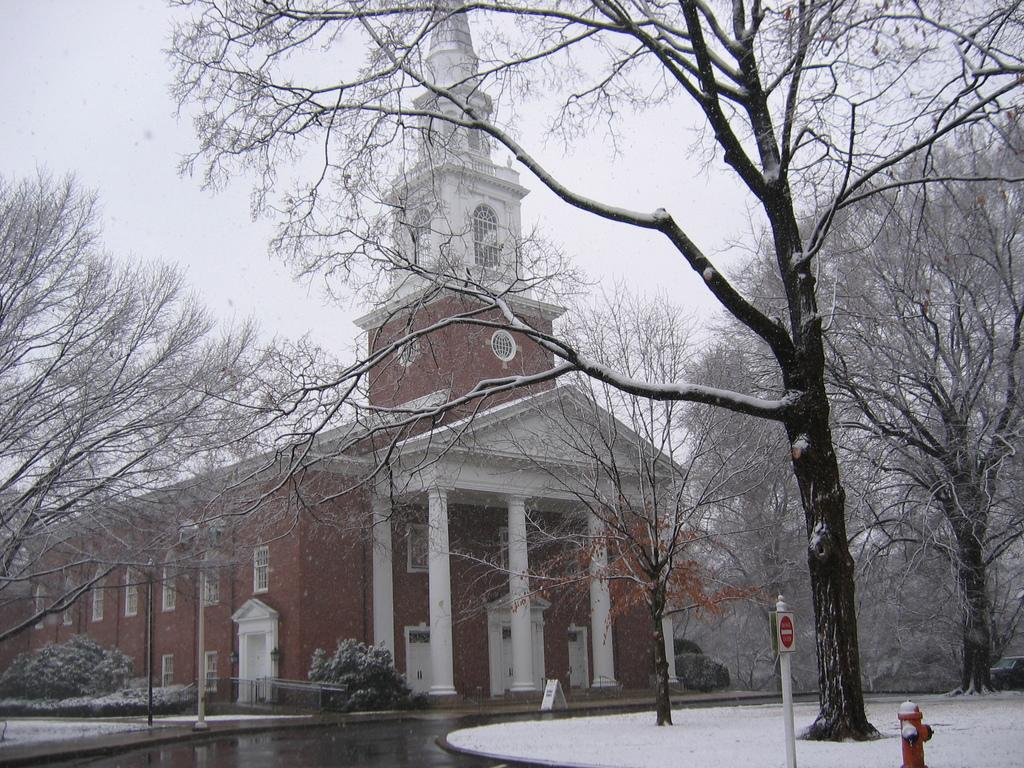What type of structure is present in the image? There is a building in the image. What natural element can be seen in the image? There is water visible in the image. What type of vegetation is present in the image? There are trees in the image. What type of fire safety equipment is present in the image? There is a hydrant in the image. What else can be seen in the image besides the mentioned elements? There are some objects in the image. What is visible in the background of the image? The sky is visible in the background of the image. Where is the dad in the image? There is no dad present in the image. What type of sack is being used by the farmer in the image? There is no farmer or sack present in the image. 